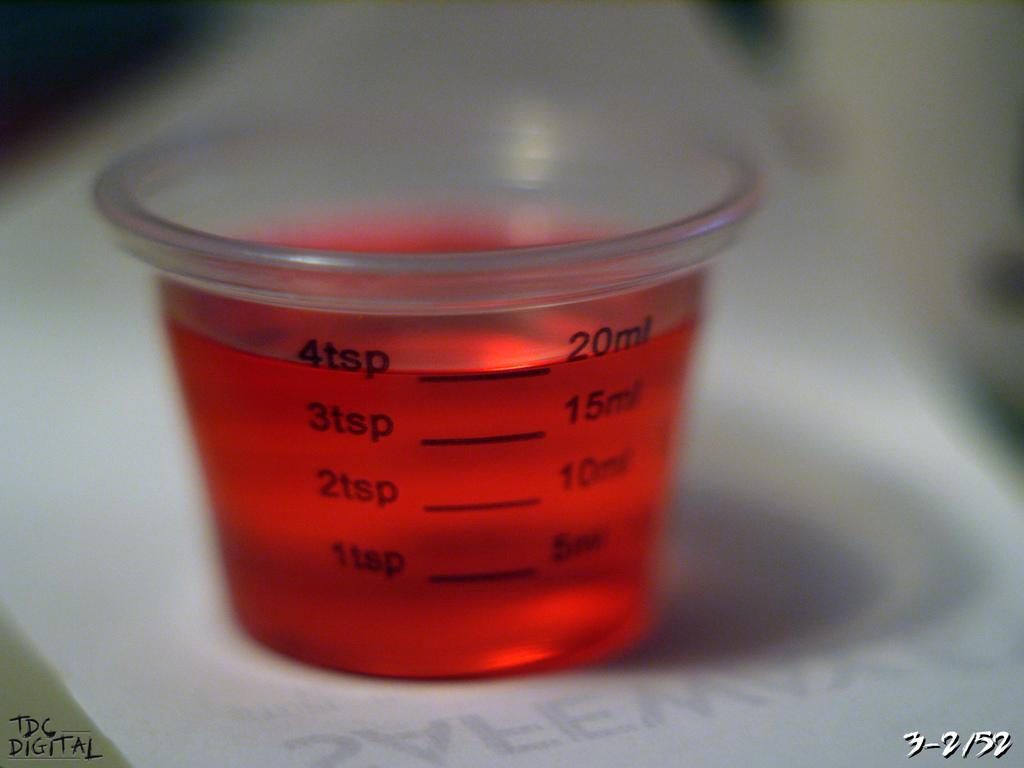<image>
Describe the image concisely. Measuring cup for medicine that holds up to 4 teaspoons. 